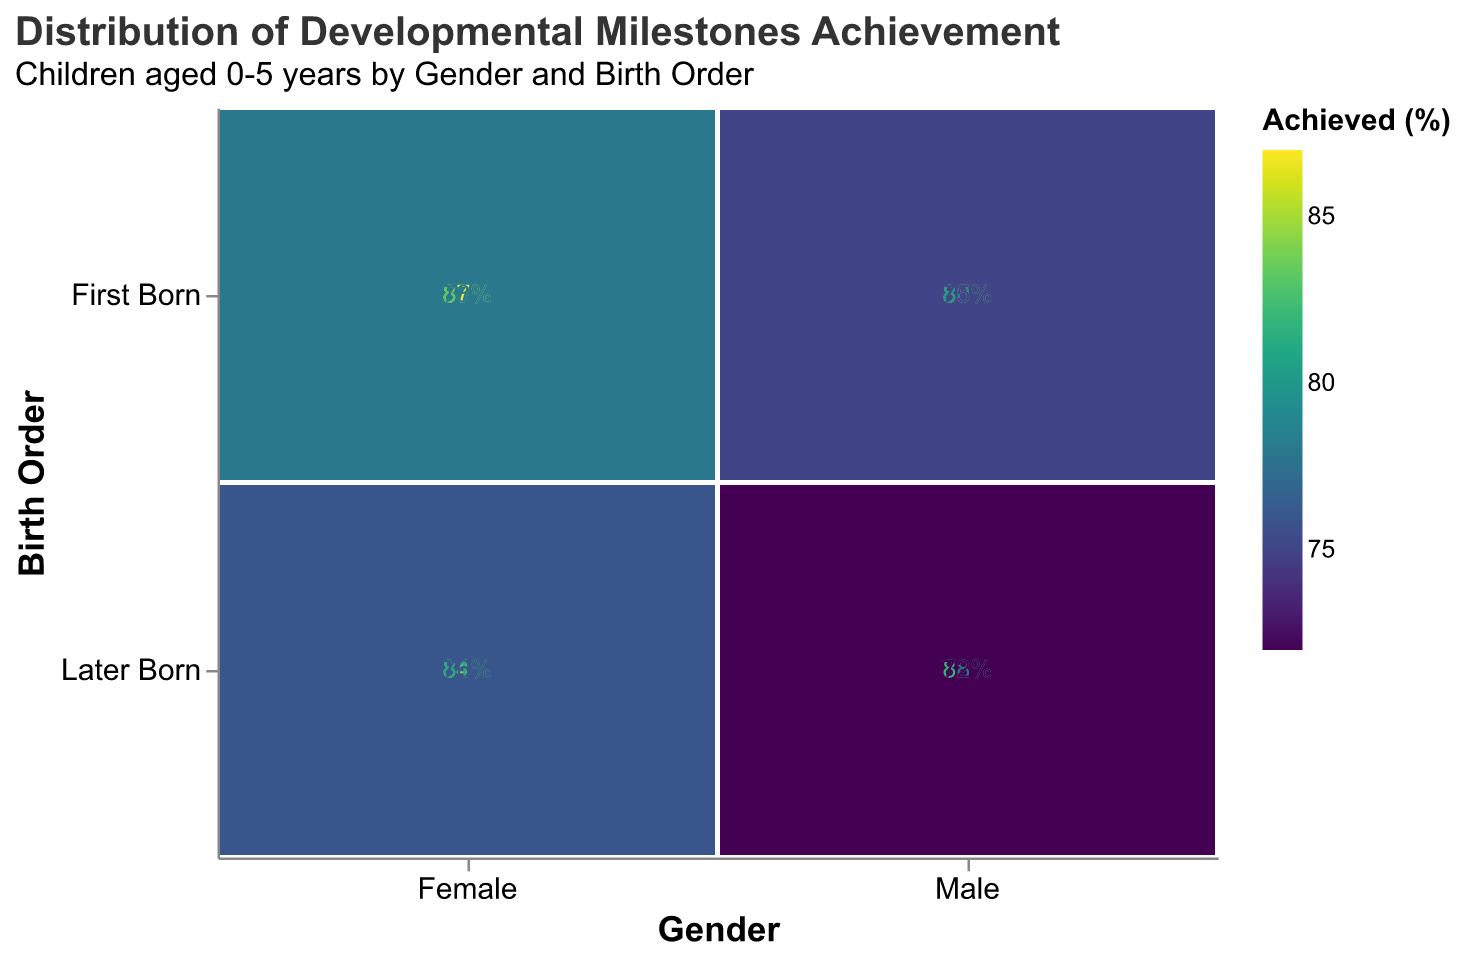What is the subtitle of the plot? The subtitle is usually found below the main title and provides additional context for the plot. In this case, it specifies the age range and the factors considered in the distribution.
Answer: "Children aged 0-5 years by Gender and Birth Order" Which milestone has the highest achievement rate for First Born Females? To find this, the 'First Born' and 'Female' categories must be examined for each milestone, looking for the highest percentage of 'Achieved'. According to the data, "Walks Alone" has the highest percentage.
Answer: "Walks Alone" How do the achievement rates of the "First Words" milestone compare between genders for later-born children? Compare the 'Achieved' percentages for 'First Words' within the 'Later Born' category for both genders. Males have 78%, and females have 81%.
Answer: Females achieve at a 3% higher rate than males for the "First Words" milestone Which category and milestone combination has the lowest achievement rate? Look through all the 'Achieved' percentages across different gender, birth order, and milestone combinations. The lowest value is 72%, which corresponds to males who are later-born and "Toilet Trained".
Answer: Males, Later Born, "Toilet Trained" What is the overall trend in achievement rates between first-born and later-born children for the "Walks Alone" milestone across genders? Analyze the 'Achieved' percentages for the "Walks Alone" milestone across both 'First Born' and 'Later Born' categories. For males, the rate drops from 85% to 82%. For females, it drops from 87% to 84%. Both genders show a slight decrease.
Answer: Slight decrease for both genders 